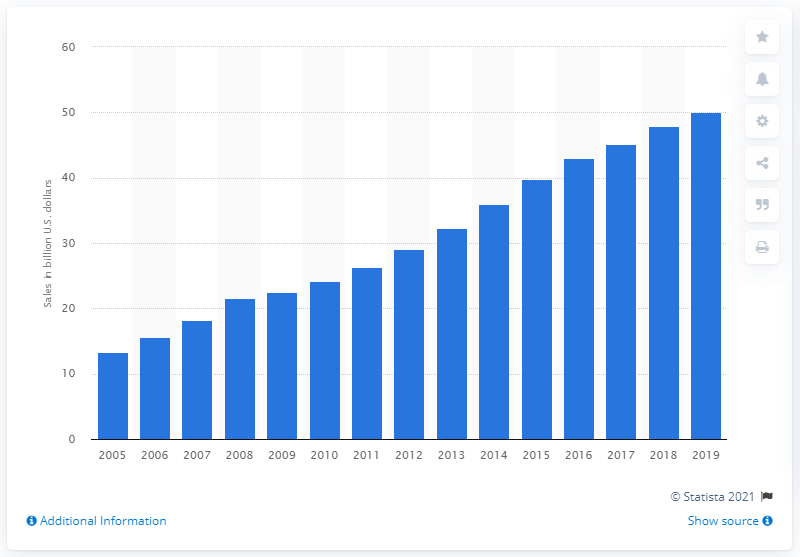Highlight a few significant elements in this photo. Organic food sales in the United States amounted to $50.07 billion in 2019. 